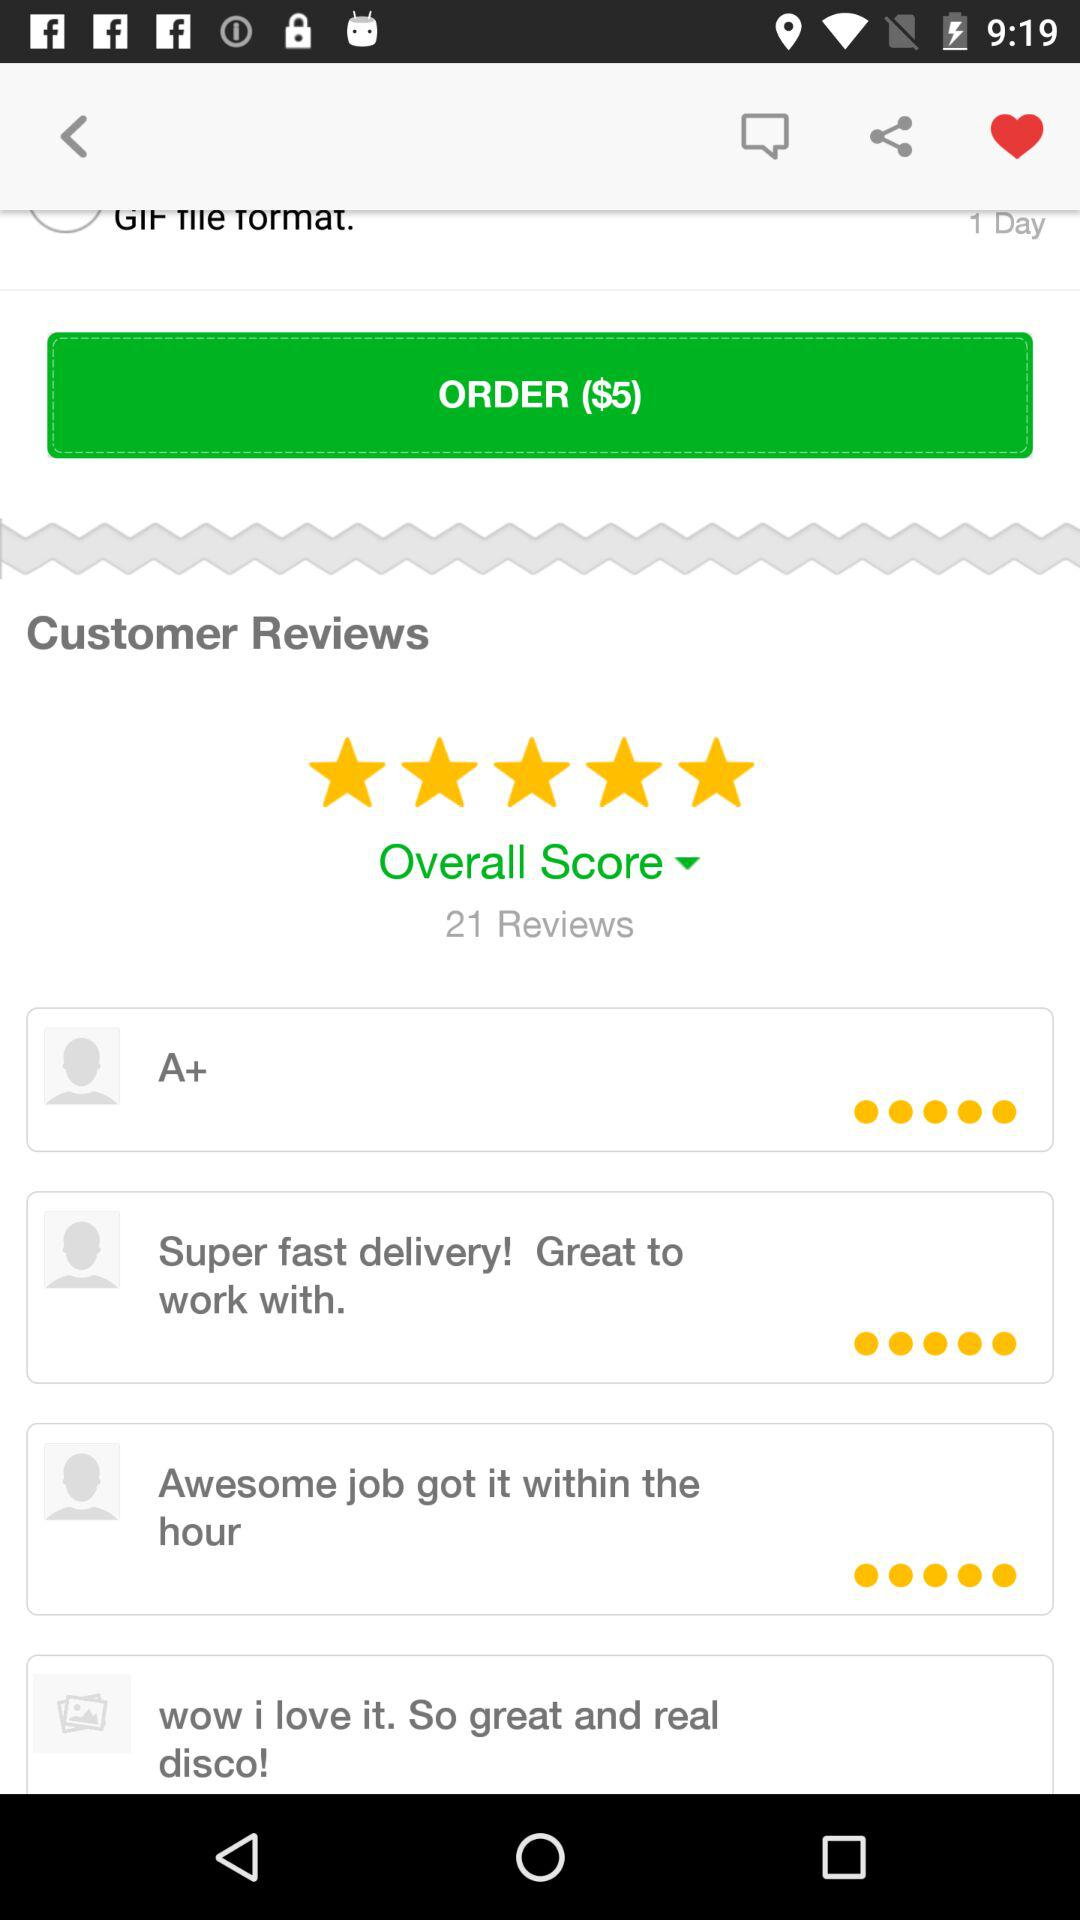How many reviews are there?
Answer the question using a single word or phrase. 21 